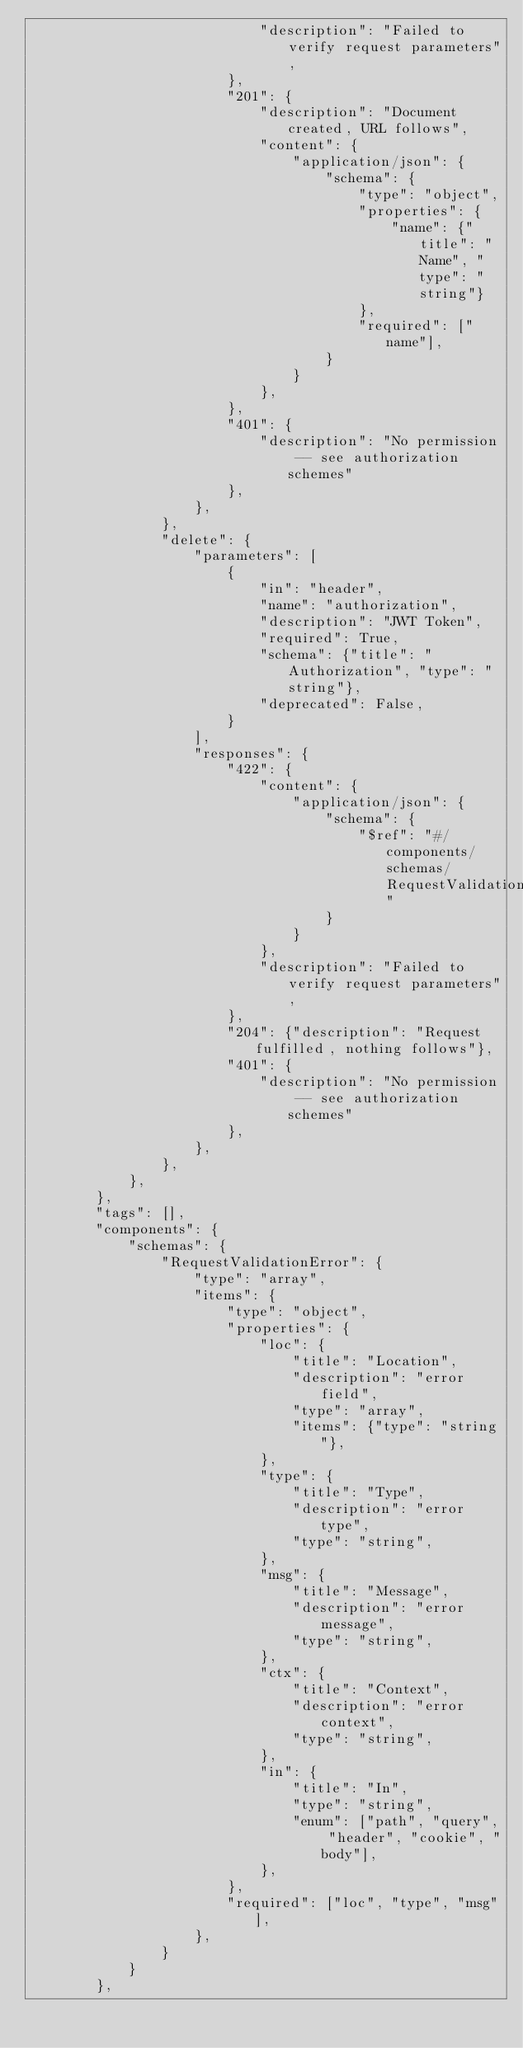<code> <loc_0><loc_0><loc_500><loc_500><_Python_>                            "description": "Failed to verify request parameters",
                        },
                        "201": {
                            "description": "Document created, URL follows",
                            "content": {
                                "application/json": {
                                    "schema": {
                                        "type": "object",
                                        "properties": {
                                            "name": {"title": "Name", "type": "string"}
                                        },
                                        "required": ["name"],
                                    }
                                }
                            },
                        },
                        "401": {
                            "description": "No permission -- see authorization schemes"
                        },
                    },
                },
                "delete": {
                    "parameters": [
                        {
                            "in": "header",
                            "name": "authorization",
                            "description": "JWT Token",
                            "required": True,
                            "schema": {"title": "Authorization", "type": "string"},
                            "deprecated": False,
                        }
                    ],
                    "responses": {
                        "422": {
                            "content": {
                                "application/json": {
                                    "schema": {
                                        "$ref": "#/components/schemas/RequestValidationError"
                                    }
                                }
                            },
                            "description": "Failed to verify request parameters",
                        },
                        "204": {"description": "Request fulfilled, nothing follows"},
                        "401": {
                            "description": "No permission -- see authorization schemes"
                        },
                    },
                },
            },
        },
        "tags": [],
        "components": {
            "schemas": {
                "RequestValidationError": {
                    "type": "array",
                    "items": {
                        "type": "object",
                        "properties": {
                            "loc": {
                                "title": "Location",
                                "description": "error field",
                                "type": "array",
                                "items": {"type": "string"},
                            },
                            "type": {
                                "title": "Type",
                                "description": "error type",
                                "type": "string",
                            },
                            "msg": {
                                "title": "Message",
                                "description": "error message",
                                "type": "string",
                            },
                            "ctx": {
                                "title": "Context",
                                "description": "error context",
                                "type": "string",
                            },
                            "in": {
                                "title": "In",
                                "type": "string",
                                "enum": ["path", "query", "header", "cookie", "body"],
                            },
                        },
                        "required": ["loc", "type", "msg"],
                    },
                }
            }
        },</code> 